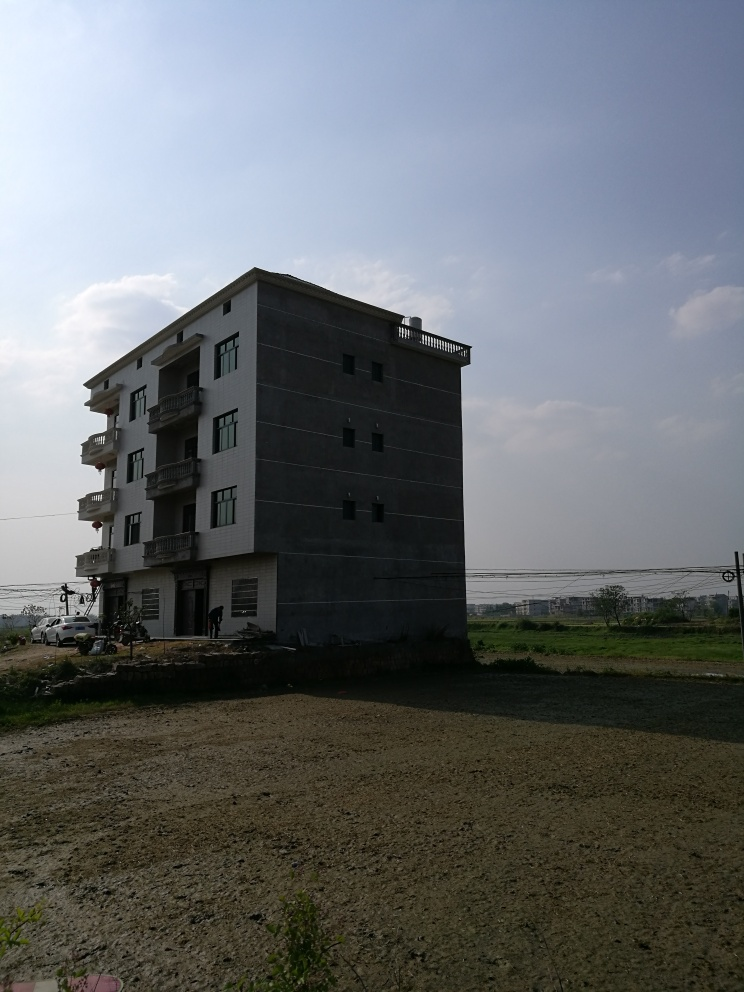What can you infer about the location or setting of the house? The house is situated in a spacious and open setting, possibly on the outskirts of a city or in a rural area. The presence of flat and empty land in the foreground and minimal neighboring structures suggest a less dense and possibly suburban or rural environment. What time of day does it seem to be in the image? Given the soft lighting and the angle of the shadows cast by the house and surrounding features, it appears to be either morning or late afternoon. 